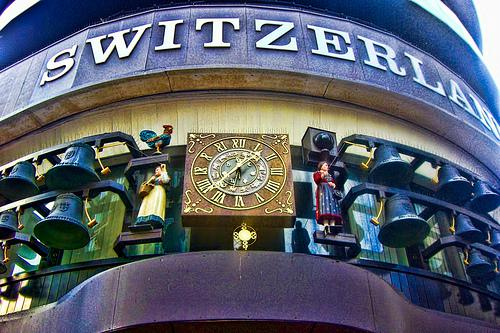Question: what color is the clock?
Choices:
A. Red.
B. Gold.
C. Black.
D. White.
Answer with the letter. Answer: B Question: what color are the bells?
Choices:
A. Black.
B. Yellow.
C. Red.
D. Grey.
Answer with the letter. Answer: A Question: what color are the figurines?
Choices:
A. Grey.
B. Pink.
C. Yellow, red, blue, and green.
D. White.
Answer with the letter. Answer: C Question: where is the clock?
Choices:
A. On the wall.
B. Against the trash can.
C. In between the figurines.
D. Beside the stereo.
Answer with the letter. Answer: C 